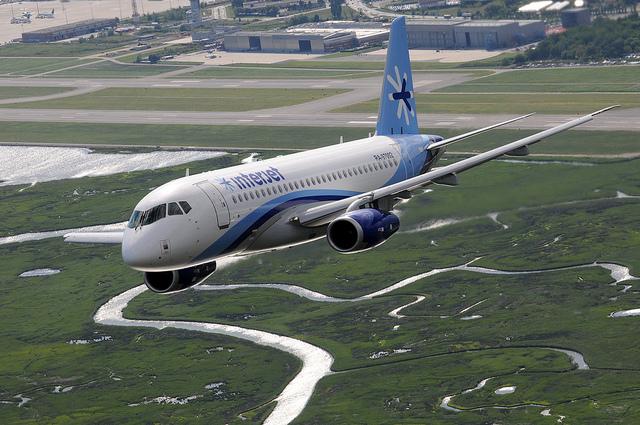Is the plane flying straight?
Keep it brief. Yes. What word is displayed near the front of the jet?
Quick response, please. Interjet. How many planes are there?
Short answer required. 1. Is this plane flying near a coastline?
Keep it brief. No. 